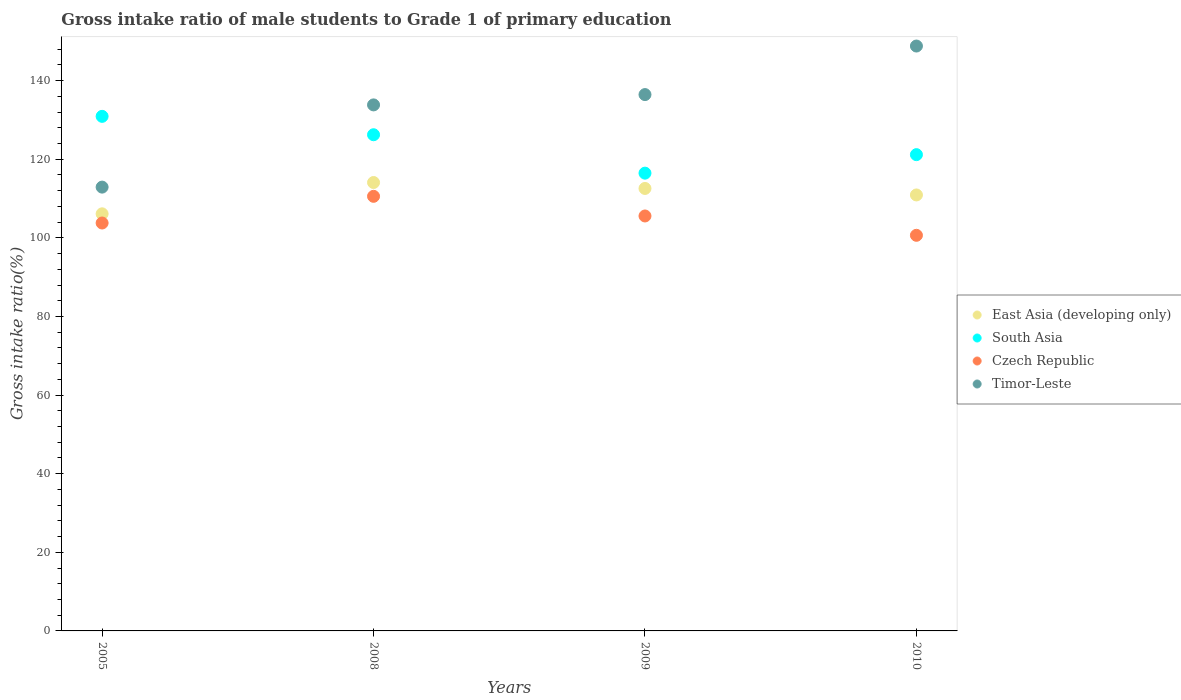Is the number of dotlines equal to the number of legend labels?
Your response must be concise. Yes. What is the gross intake ratio in East Asia (developing only) in 2010?
Your answer should be very brief. 110.91. Across all years, what is the maximum gross intake ratio in Timor-Leste?
Provide a succinct answer. 148.8. Across all years, what is the minimum gross intake ratio in South Asia?
Your answer should be very brief. 116.46. In which year was the gross intake ratio in Timor-Leste minimum?
Give a very brief answer. 2005. What is the total gross intake ratio in Timor-Leste in the graph?
Give a very brief answer. 531.98. What is the difference between the gross intake ratio in Czech Republic in 2005 and that in 2009?
Your response must be concise. -1.79. What is the difference between the gross intake ratio in Timor-Leste in 2005 and the gross intake ratio in East Asia (developing only) in 2009?
Provide a short and direct response. 0.34. What is the average gross intake ratio in South Asia per year?
Your response must be concise. 123.69. In the year 2010, what is the difference between the gross intake ratio in East Asia (developing only) and gross intake ratio in Czech Republic?
Provide a succinct answer. 10.27. What is the ratio of the gross intake ratio in Czech Republic in 2008 to that in 2010?
Keep it short and to the point. 1.1. Is the difference between the gross intake ratio in East Asia (developing only) in 2009 and 2010 greater than the difference between the gross intake ratio in Czech Republic in 2009 and 2010?
Offer a terse response. No. What is the difference between the highest and the second highest gross intake ratio in South Asia?
Give a very brief answer. 4.68. What is the difference between the highest and the lowest gross intake ratio in South Asia?
Give a very brief answer. 14.45. In how many years, is the gross intake ratio in Czech Republic greater than the average gross intake ratio in Czech Republic taken over all years?
Give a very brief answer. 2. Is the sum of the gross intake ratio in Timor-Leste in 2008 and 2010 greater than the maximum gross intake ratio in Czech Republic across all years?
Make the answer very short. Yes. Is it the case that in every year, the sum of the gross intake ratio in Czech Republic and gross intake ratio in East Asia (developing only)  is greater than the sum of gross intake ratio in Timor-Leste and gross intake ratio in South Asia?
Make the answer very short. Yes. Does the gross intake ratio in Timor-Leste monotonically increase over the years?
Your response must be concise. Yes. How many dotlines are there?
Offer a terse response. 4. What is the difference between two consecutive major ticks on the Y-axis?
Ensure brevity in your answer.  20. Does the graph contain any zero values?
Provide a short and direct response. No. Does the graph contain grids?
Keep it short and to the point. No. Where does the legend appear in the graph?
Your answer should be very brief. Center right. How many legend labels are there?
Provide a short and direct response. 4. What is the title of the graph?
Keep it short and to the point. Gross intake ratio of male students to Grade 1 of primary education. What is the label or title of the X-axis?
Make the answer very short. Years. What is the label or title of the Y-axis?
Offer a very short reply. Gross intake ratio(%). What is the Gross intake ratio(%) in East Asia (developing only) in 2005?
Give a very brief answer. 106.11. What is the Gross intake ratio(%) of South Asia in 2005?
Keep it short and to the point. 130.91. What is the Gross intake ratio(%) of Czech Republic in 2005?
Your response must be concise. 103.78. What is the Gross intake ratio(%) of Timor-Leste in 2005?
Offer a terse response. 112.91. What is the Gross intake ratio(%) in East Asia (developing only) in 2008?
Keep it short and to the point. 114.08. What is the Gross intake ratio(%) of South Asia in 2008?
Keep it short and to the point. 126.23. What is the Gross intake ratio(%) of Czech Republic in 2008?
Ensure brevity in your answer.  110.57. What is the Gross intake ratio(%) of Timor-Leste in 2008?
Keep it short and to the point. 133.82. What is the Gross intake ratio(%) in East Asia (developing only) in 2009?
Ensure brevity in your answer.  112.57. What is the Gross intake ratio(%) of South Asia in 2009?
Ensure brevity in your answer.  116.46. What is the Gross intake ratio(%) in Czech Republic in 2009?
Give a very brief answer. 105.57. What is the Gross intake ratio(%) in Timor-Leste in 2009?
Ensure brevity in your answer.  136.45. What is the Gross intake ratio(%) of East Asia (developing only) in 2010?
Your answer should be compact. 110.91. What is the Gross intake ratio(%) in South Asia in 2010?
Provide a succinct answer. 121.17. What is the Gross intake ratio(%) in Czech Republic in 2010?
Provide a short and direct response. 100.65. What is the Gross intake ratio(%) in Timor-Leste in 2010?
Offer a very short reply. 148.8. Across all years, what is the maximum Gross intake ratio(%) in East Asia (developing only)?
Your answer should be compact. 114.08. Across all years, what is the maximum Gross intake ratio(%) in South Asia?
Your answer should be compact. 130.91. Across all years, what is the maximum Gross intake ratio(%) in Czech Republic?
Offer a very short reply. 110.57. Across all years, what is the maximum Gross intake ratio(%) in Timor-Leste?
Provide a succinct answer. 148.8. Across all years, what is the minimum Gross intake ratio(%) of East Asia (developing only)?
Provide a succinct answer. 106.11. Across all years, what is the minimum Gross intake ratio(%) of South Asia?
Give a very brief answer. 116.46. Across all years, what is the minimum Gross intake ratio(%) in Czech Republic?
Offer a very short reply. 100.65. Across all years, what is the minimum Gross intake ratio(%) in Timor-Leste?
Provide a short and direct response. 112.91. What is the total Gross intake ratio(%) in East Asia (developing only) in the graph?
Provide a succinct answer. 443.67. What is the total Gross intake ratio(%) of South Asia in the graph?
Ensure brevity in your answer.  494.77. What is the total Gross intake ratio(%) of Czech Republic in the graph?
Your answer should be very brief. 420.56. What is the total Gross intake ratio(%) in Timor-Leste in the graph?
Your answer should be compact. 531.98. What is the difference between the Gross intake ratio(%) of East Asia (developing only) in 2005 and that in 2008?
Provide a short and direct response. -7.97. What is the difference between the Gross intake ratio(%) of South Asia in 2005 and that in 2008?
Ensure brevity in your answer.  4.68. What is the difference between the Gross intake ratio(%) in Czech Republic in 2005 and that in 2008?
Ensure brevity in your answer.  -6.79. What is the difference between the Gross intake ratio(%) in Timor-Leste in 2005 and that in 2008?
Make the answer very short. -20.92. What is the difference between the Gross intake ratio(%) in East Asia (developing only) in 2005 and that in 2009?
Your answer should be compact. -6.46. What is the difference between the Gross intake ratio(%) in South Asia in 2005 and that in 2009?
Keep it short and to the point. 14.45. What is the difference between the Gross intake ratio(%) of Czech Republic in 2005 and that in 2009?
Provide a succinct answer. -1.79. What is the difference between the Gross intake ratio(%) in Timor-Leste in 2005 and that in 2009?
Provide a succinct answer. -23.54. What is the difference between the Gross intake ratio(%) of East Asia (developing only) in 2005 and that in 2010?
Your answer should be very brief. -4.8. What is the difference between the Gross intake ratio(%) of South Asia in 2005 and that in 2010?
Your answer should be very brief. 9.74. What is the difference between the Gross intake ratio(%) of Czech Republic in 2005 and that in 2010?
Ensure brevity in your answer.  3.13. What is the difference between the Gross intake ratio(%) of Timor-Leste in 2005 and that in 2010?
Offer a very short reply. -35.89. What is the difference between the Gross intake ratio(%) in East Asia (developing only) in 2008 and that in 2009?
Your answer should be very brief. 1.51. What is the difference between the Gross intake ratio(%) in South Asia in 2008 and that in 2009?
Make the answer very short. 9.77. What is the difference between the Gross intake ratio(%) of Czech Republic in 2008 and that in 2009?
Ensure brevity in your answer.  5. What is the difference between the Gross intake ratio(%) of Timor-Leste in 2008 and that in 2009?
Give a very brief answer. -2.62. What is the difference between the Gross intake ratio(%) of East Asia (developing only) in 2008 and that in 2010?
Give a very brief answer. 3.16. What is the difference between the Gross intake ratio(%) of South Asia in 2008 and that in 2010?
Offer a terse response. 5.07. What is the difference between the Gross intake ratio(%) in Czech Republic in 2008 and that in 2010?
Give a very brief answer. 9.92. What is the difference between the Gross intake ratio(%) in Timor-Leste in 2008 and that in 2010?
Your answer should be very brief. -14.97. What is the difference between the Gross intake ratio(%) in East Asia (developing only) in 2009 and that in 2010?
Your answer should be compact. 1.66. What is the difference between the Gross intake ratio(%) in South Asia in 2009 and that in 2010?
Your answer should be compact. -4.71. What is the difference between the Gross intake ratio(%) of Czech Republic in 2009 and that in 2010?
Offer a very short reply. 4.92. What is the difference between the Gross intake ratio(%) in Timor-Leste in 2009 and that in 2010?
Ensure brevity in your answer.  -12.35. What is the difference between the Gross intake ratio(%) of East Asia (developing only) in 2005 and the Gross intake ratio(%) of South Asia in 2008?
Your answer should be very brief. -20.12. What is the difference between the Gross intake ratio(%) in East Asia (developing only) in 2005 and the Gross intake ratio(%) in Czech Republic in 2008?
Your answer should be compact. -4.45. What is the difference between the Gross intake ratio(%) of East Asia (developing only) in 2005 and the Gross intake ratio(%) of Timor-Leste in 2008?
Provide a succinct answer. -27.71. What is the difference between the Gross intake ratio(%) of South Asia in 2005 and the Gross intake ratio(%) of Czech Republic in 2008?
Make the answer very short. 20.34. What is the difference between the Gross intake ratio(%) in South Asia in 2005 and the Gross intake ratio(%) in Timor-Leste in 2008?
Make the answer very short. -2.92. What is the difference between the Gross intake ratio(%) of Czech Republic in 2005 and the Gross intake ratio(%) of Timor-Leste in 2008?
Give a very brief answer. -30.05. What is the difference between the Gross intake ratio(%) in East Asia (developing only) in 2005 and the Gross intake ratio(%) in South Asia in 2009?
Ensure brevity in your answer.  -10.35. What is the difference between the Gross intake ratio(%) in East Asia (developing only) in 2005 and the Gross intake ratio(%) in Czech Republic in 2009?
Your response must be concise. 0.55. What is the difference between the Gross intake ratio(%) in East Asia (developing only) in 2005 and the Gross intake ratio(%) in Timor-Leste in 2009?
Offer a terse response. -30.33. What is the difference between the Gross intake ratio(%) in South Asia in 2005 and the Gross intake ratio(%) in Czech Republic in 2009?
Give a very brief answer. 25.34. What is the difference between the Gross intake ratio(%) in South Asia in 2005 and the Gross intake ratio(%) in Timor-Leste in 2009?
Provide a short and direct response. -5.54. What is the difference between the Gross intake ratio(%) in Czech Republic in 2005 and the Gross intake ratio(%) in Timor-Leste in 2009?
Give a very brief answer. -32.67. What is the difference between the Gross intake ratio(%) of East Asia (developing only) in 2005 and the Gross intake ratio(%) of South Asia in 2010?
Make the answer very short. -15.05. What is the difference between the Gross intake ratio(%) of East Asia (developing only) in 2005 and the Gross intake ratio(%) of Czech Republic in 2010?
Make the answer very short. 5.47. What is the difference between the Gross intake ratio(%) in East Asia (developing only) in 2005 and the Gross intake ratio(%) in Timor-Leste in 2010?
Provide a succinct answer. -42.69. What is the difference between the Gross intake ratio(%) in South Asia in 2005 and the Gross intake ratio(%) in Czech Republic in 2010?
Keep it short and to the point. 30.26. What is the difference between the Gross intake ratio(%) of South Asia in 2005 and the Gross intake ratio(%) of Timor-Leste in 2010?
Keep it short and to the point. -17.89. What is the difference between the Gross intake ratio(%) in Czech Republic in 2005 and the Gross intake ratio(%) in Timor-Leste in 2010?
Provide a short and direct response. -45.02. What is the difference between the Gross intake ratio(%) in East Asia (developing only) in 2008 and the Gross intake ratio(%) in South Asia in 2009?
Offer a terse response. -2.38. What is the difference between the Gross intake ratio(%) of East Asia (developing only) in 2008 and the Gross intake ratio(%) of Czech Republic in 2009?
Keep it short and to the point. 8.51. What is the difference between the Gross intake ratio(%) in East Asia (developing only) in 2008 and the Gross intake ratio(%) in Timor-Leste in 2009?
Your answer should be very brief. -22.37. What is the difference between the Gross intake ratio(%) of South Asia in 2008 and the Gross intake ratio(%) of Czech Republic in 2009?
Provide a short and direct response. 20.66. What is the difference between the Gross intake ratio(%) in South Asia in 2008 and the Gross intake ratio(%) in Timor-Leste in 2009?
Provide a succinct answer. -10.22. What is the difference between the Gross intake ratio(%) in Czech Republic in 2008 and the Gross intake ratio(%) in Timor-Leste in 2009?
Keep it short and to the point. -25.88. What is the difference between the Gross intake ratio(%) in East Asia (developing only) in 2008 and the Gross intake ratio(%) in South Asia in 2010?
Your response must be concise. -7.09. What is the difference between the Gross intake ratio(%) in East Asia (developing only) in 2008 and the Gross intake ratio(%) in Czech Republic in 2010?
Keep it short and to the point. 13.43. What is the difference between the Gross intake ratio(%) of East Asia (developing only) in 2008 and the Gross intake ratio(%) of Timor-Leste in 2010?
Provide a short and direct response. -34.72. What is the difference between the Gross intake ratio(%) in South Asia in 2008 and the Gross intake ratio(%) in Czech Republic in 2010?
Provide a succinct answer. 25.58. What is the difference between the Gross intake ratio(%) of South Asia in 2008 and the Gross intake ratio(%) of Timor-Leste in 2010?
Your response must be concise. -22.57. What is the difference between the Gross intake ratio(%) in Czech Republic in 2008 and the Gross intake ratio(%) in Timor-Leste in 2010?
Offer a terse response. -38.23. What is the difference between the Gross intake ratio(%) of East Asia (developing only) in 2009 and the Gross intake ratio(%) of South Asia in 2010?
Keep it short and to the point. -8.6. What is the difference between the Gross intake ratio(%) in East Asia (developing only) in 2009 and the Gross intake ratio(%) in Czech Republic in 2010?
Keep it short and to the point. 11.92. What is the difference between the Gross intake ratio(%) of East Asia (developing only) in 2009 and the Gross intake ratio(%) of Timor-Leste in 2010?
Offer a terse response. -36.23. What is the difference between the Gross intake ratio(%) of South Asia in 2009 and the Gross intake ratio(%) of Czech Republic in 2010?
Your response must be concise. 15.81. What is the difference between the Gross intake ratio(%) in South Asia in 2009 and the Gross intake ratio(%) in Timor-Leste in 2010?
Ensure brevity in your answer.  -32.34. What is the difference between the Gross intake ratio(%) of Czech Republic in 2009 and the Gross intake ratio(%) of Timor-Leste in 2010?
Give a very brief answer. -43.23. What is the average Gross intake ratio(%) of East Asia (developing only) per year?
Provide a short and direct response. 110.92. What is the average Gross intake ratio(%) in South Asia per year?
Give a very brief answer. 123.69. What is the average Gross intake ratio(%) in Czech Republic per year?
Your answer should be compact. 105.14. What is the average Gross intake ratio(%) of Timor-Leste per year?
Provide a succinct answer. 132.99. In the year 2005, what is the difference between the Gross intake ratio(%) of East Asia (developing only) and Gross intake ratio(%) of South Asia?
Your answer should be compact. -24.8. In the year 2005, what is the difference between the Gross intake ratio(%) in East Asia (developing only) and Gross intake ratio(%) in Czech Republic?
Provide a succinct answer. 2.34. In the year 2005, what is the difference between the Gross intake ratio(%) in East Asia (developing only) and Gross intake ratio(%) in Timor-Leste?
Your answer should be compact. -6.79. In the year 2005, what is the difference between the Gross intake ratio(%) in South Asia and Gross intake ratio(%) in Czech Republic?
Offer a terse response. 27.13. In the year 2005, what is the difference between the Gross intake ratio(%) in South Asia and Gross intake ratio(%) in Timor-Leste?
Ensure brevity in your answer.  18. In the year 2005, what is the difference between the Gross intake ratio(%) of Czech Republic and Gross intake ratio(%) of Timor-Leste?
Offer a terse response. -9.13. In the year 2008, what is the difference between the Gross intake ratio(%) in East Asia (developing only) and Gross intake ratio(%) in South Asia?
Offer a very short reply. -12.15. In the year 2008, what is the difference between the Gross intake ratio(%) of East Asia (developing only) and Gross intake ratio(%) of Czech Republic?
Ensure brevity in your answer.  3.51. In the year 2008, what is the difference between the Gross intake ratio(%) in East Asia (developing only) and Gross intake ratio(%) in Timor-Leste?
Provide a succinct answer. -19.75. In the year 2008, what is the difference between the Gross intake ratio(%) in South Asia and Gross intake ratio(%) in Czech Republic?
Ensure brevity in your answer.  15.66. In the year 2008, what is the difference between the Gross intake ratio(%) in South Asia and Gross intake ratio(%) in Timor-Leste?
Your answer should be compact. -7.59. In the year 2008, what is the difference between the Gross intake ratio(%) in Czech Republic and Gross intake ratio(%) in Timor-Leste?
Provide a short and direct response. -23.26. In the year 2009, what is the difference between the Gross intake ratio(%) of East Asia (developing only) and Gross intake ratio(%) of South Asia?
Your response must be concise. -3.89. In the year 2009, what is the difference between the Gross intake ratio(%) in East Asia (developing only) and Gross intake ratio(%) in Czech Republic?
Your response must be concise. 7. In the year 2009, what is the difference between the Gross intake ratio(%) in East Asia (developing only) and Gross intake ratio(%) in Timor-Leste?
Keep it short and to the point. -23.88. In the year 2009, what is the difference between the Gross intake ratio(%) of South Asia and Gross intake ratio(%) of Czech Republic?
Your answer should be compact. 10.89. In the year 2009, what is the difference between the Gross intake ratio(%) in South Asia and Gross intake ratio(%) in Timor-Leste?
Offer a very short reply. -19.99. In the year 2009, what is the difference between the Gross intake ratio(%) of Czech Republic and Gross intake ratio(%) of Timor-Leste?
Give a very brief answer. -30.88. In the year 2010, what is the difference between the Gross intake ratio(%) of East Asia (developing only) and Gross intake ratio(%) of South Asia?
Make the answer very short. -10.25. In the year 2010, what is the difference between the Gross intake ratio(%) of East Asia (developing only) and Gross intake ratio(%) of Czech Republic?
Provide a succinct answer. 10.27. In the year 2010, what is the difference between the Gross intake ratio(%) in East Asia (developing only) and Gross intake ratio(%) in Timor-Leste?
Provide a succinct answer. -37.88. In the year 2010, what is the difference between the Gross intake ratio(%) in South Asia and Gross intake ratio(%) in Czech Republic?
Your answer should be very brief. 20.52. In the year 2010, what is the difference between the Gross intake ratio(%) in South Asia and Gross intake ratio(%) in Timor-Leste?
Your answer should be compact. -27.63. In the year 2010, what is the difference between the Gross intake ratio(%) in Czech Republic and Gross intake ratio(%) in Timor-Leste?
Your response must be concise. -48.15. What is the ratio of the Gross intake ratio(%) of East Asia (developing only) in 2005 to that in 2008?
Ensure brevity in your answer.  0.93. What is the ratio of the Gross intake ratio(%) in South Asia in 2005 to that in 2008?
Offer a very short reply. 1.04. What is the ratio of the Gross intake ratio(%) of Czech Republic in 2005 to that in 2008?
Offer a terse response. 0.94. What is the ratio of the Gross intake ratio(%) of Timor-Leste in 2005 to that in 2008?
Offer a very short reply. 0.84. What is the ratio of the Gross intake ratio(%) in East Asia (developing only) in 2005 to that in 2009?
Provide a succinct answer. 0.94. What is the ratio of the Gross intake ratio(%) in South Asia in 2005 to that in 2009?
Your answer should be very brief. 1.12. What is the ratio of the Gross intake ratio(%) in Czech Republic in 2005 to that in 2009?
Make the answer very short. 0.98. What is the ratio of the Gross intake ratio(%) in Timor-Leste in 2005 to that in 2009?
Offer a very short reply. 0.83. What is the ratio of the Gross intake ratio(%) in East Asia (developing only) in 2005 to that in 2010?
Keep it short and to the point. 0.96. What is the ratio of the Gross intake ratio(%) of South Asia in 2005 to that in 2010?
Provide a succinct answer. 1.08. What is the ratio of the Gross intake ratio(%) of Czech Republic in 2005 to that in 2010?
Make the answer very short. 1.03. What is the ratio of the Gross intake ratio(%) in Timor-Leste in 2005 to that in 2010?
Provide a short and direct response. 0.76. What is the ratio of the Gross intake ratio(%) in East Asia (developing only) in 2008 to that in 2009?
Your answer should be very brief. 1.01. What is the ratio of the Gross intake ratio(%) in South Asia in 2008 to that in 2009?
Ensure brevity in your answer.  1.08. What is the ratio of the Gross intake ratio(%) of Czech Republic in 2008 to that in 2009?
Your response must be concise. 1.05. What is the ratio of the Gross intake ratio(%) of Timor-Leste in 2008 to that in 2009?
Your response must be concise. 0.98. What is the ratio of the Gross intake ratio(%) in East Asia (developing only) in 2008 to that in 2010?
Your response must be concise. 1.03. What is the ratio of the Gross intake ratio(%) in South Asia in 2008 to that in 2010?
Your answer should be compact. 1.04. What is the ratio of the Gross intake ratio(%) in Czech Republic in 2008 to that in 2010?
Your answer should be very brief. 1.1. What is the ratio of the Gross intake ratio(%) in Timor-Leste in 2008 to that in 2010?
Your response must be concise. 0.9. What is the ratio of the Gross intake ratio(%) in East Asia (developing only) in 2009 to that in 2010?
Your answer should be compact. 1.01. What is the ratio of the Gross intake ratio(%) of South Asia in 2009 to that in 2010?
Give a very brief answer. 0.96. What is the ratio of the Gross intake ratio(%) in Czech Republic in 2009 to that in 2010?
Your answer should be compact. 1.05. What is the ratio of the Gross intake ratio(%) in Timor-Leste in 2009 to that in 2010?
Your response must be concise. 0.92. What is the difference between the highest and the second highest Gross intake ratio(%) in East Asia (developing only)?
Keep it short and to the point. 1.51. What is the difference between the highest and the second highest Gross intake ratio(%) of South Asia?
Provide a short and direct response. 4.68. What is the difference between the highest and the second highest Gross intake ratio(%) of Czech Republic?
Your response must be concise. 5. What is the difference between the highest and the second highest Gross intake ratio(%) in Timor-Leste?
Keep it short and to the point. 12.35. What is the difference between the highest and the lowest Gross intake ratio(%) of East Asia (developing only)?
Ensure brevity in your answer.  7.97. What is the difference between the highest and the lowest Gross intake ratio(%) of South Asia?
Offer a very short reply. 14.45. What is the difference between the highest and the lowest Gross intake ratio(%) in Czech Republic?
Your response must be concise. 9.92. What is the difference between the highest and the lowest Gross intake ratio(%) in Timor-Leste?
Give a very brief answer. 35.89. 